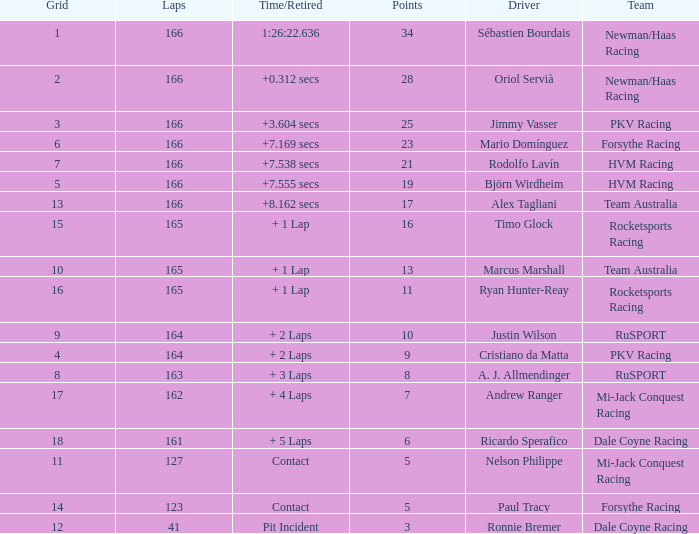What grid is the lowest when the time/retired is + 5 laps and the laps is less than 161? None. Parse the full table. {'header': ['Grid', 'Laps', 'Time/Retired', 'Points', 'Driver', 'Team'], 'rows': [['1', '166', '1:26:22.636', '34', 'Sébastien Bourdais', 'Newman/Haas Racing'], ['2', '166', '+0.312 secs', '28', 'Oriol Servià', 'Newman/Haas Racing'], ['3', '166', '+3.604 secs', '25', 'Jimmy Vasser', 'PKV Racing'], ['6', '166', '+7.169 secs', '23', 'Mario Domínguez', 'Forsythe Racing'], ['7', '166', '+7.538 secs', '21', 'Rodolfo Lavín', 'HVM Racing'], ['5', '166', '+7.555 secs', '19', 'Björn Wirdheim', 'HVM Racing'], ['13', '166', '+8.162 secs', '17', 'Alex Tagliani', 'Team Australia'], ['15', '165', '+ 1 Lap', '16', 'Timo Glock', 'Rocketsports Racing'], ['10', '165', '+ 1 Lap', '13', 'Marcus Marshall', 'Team Australia'], ['16', '165', '+ 1 Lap', '11', 'Ryan Hunter-Reay', 'Rocketsports Racing'], ['9', '164', '+ 2 Laps', '10', 'Justin Wilson', 'RuSPORT'], ['4', '164', '+ 2 Laps', '9', 'Cristiano da Matta', 'PKV Racing'], ['8', '163', '+ 3 Laps', '8', 'A. J. Allmendinger', 'RuSPORT'], ['17', '162', '+ 4 Laps', '7', 'Andrew Ranger', 'Mi-Jack Conquest Racing'], ['18', '161', '+ 5 Laps', '6', 'Ricardo Sperafico', 'Dale Coyne Racing'], ['11', '127', 'Contact', '5', 'Nelson Philippe', 'Mi-Jack Conquest Racing'], ['14', '123', 'Contact', '5', 'Paul Tracy', 'Forsythe Racing'], ['12', '41', 'Pit Incident', '3', 'Ronnie Bremer', 'Dale Coyne Racing']]} 